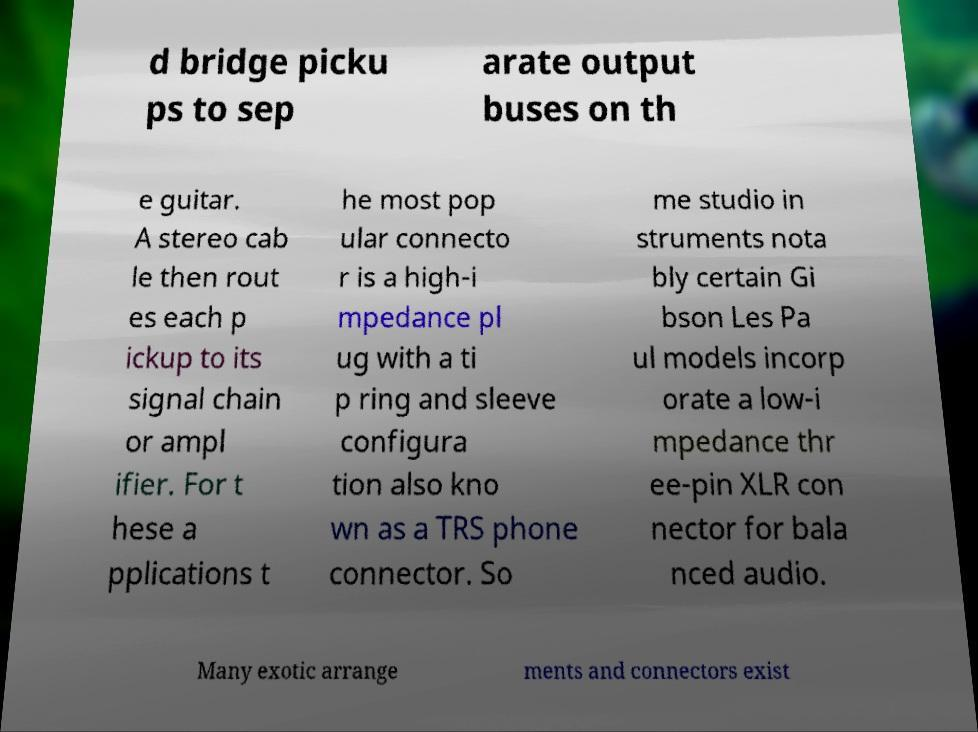Can you read and provide the text displayed in the image?This photo seems to have some interesting text. Can you extract and type it out for me? d bridge picku ps to sep arate output buses on th e guitar. A stereo cab le then rout es each p ickup to its signal chain or ampl ifier. For t hese a pplications t he most pop ular connecto r is a high-i mpedance pl ug with a ti p ring and sleeve configura tion also kno wn as a TRS phone connector. So me studio in struments nota bly certain Gi bson Les Pa ul models incorp orate a low-i mpedance thr ee-pin XLR con nector for bala nced audio. Many exotic arrange ments and connectors exist 